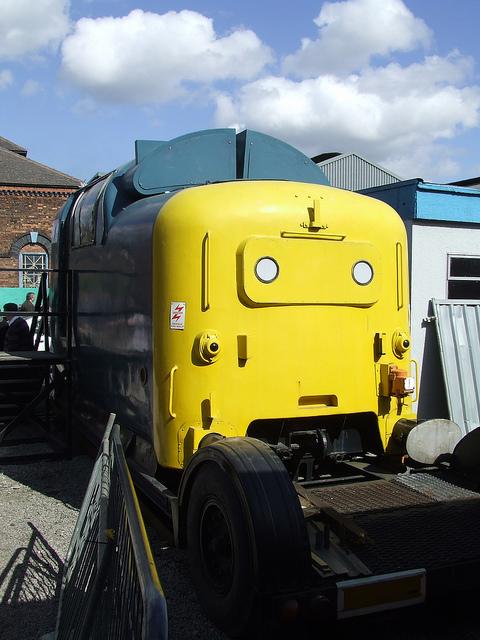What is the weather like?
Keep it brief. Sunny. What color is the vehicle?
Write a very short answer. Yellow. Does this train carry cars behind it?
Concise answer only. No. 